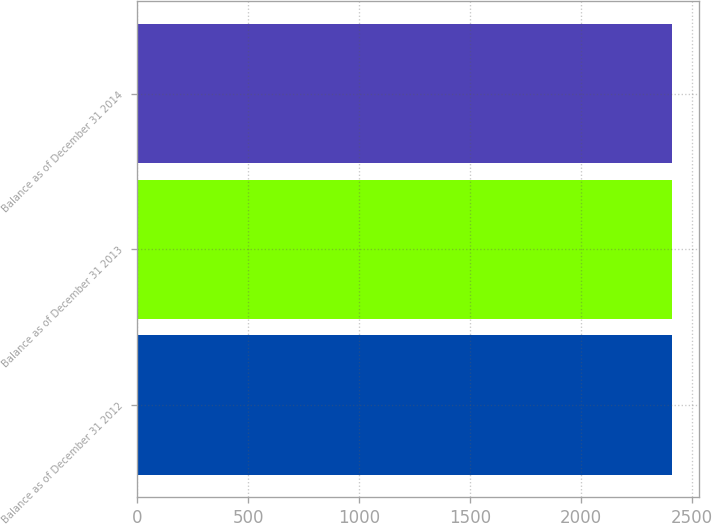Convert chart to OTSL. <chart><loc_0><loc_0><loc_500><loc_500><bar_chart><fcel>Balance as of December 31 2012<fcel>Balance as of December 31 2013<fcel>Balance as of December 31 2014<nl><fcel>2410<fcel>2410.1<fcel>2410.2<nl></chart> 